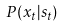Convert formula to latex. <formula><loc_0><loc_0><loc_500><loc_500>P ( x _ { t } | s _ { t } )</formula> 